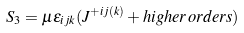Convert formula to latex. <formula><loc_0><loc_0><loc_500><loc_500>S _ { 3 } = \mu \epsilon _ { i j k } ( J ^ { + i j ( k ) } + h i g h e r \, o r d e r s )</formula> 